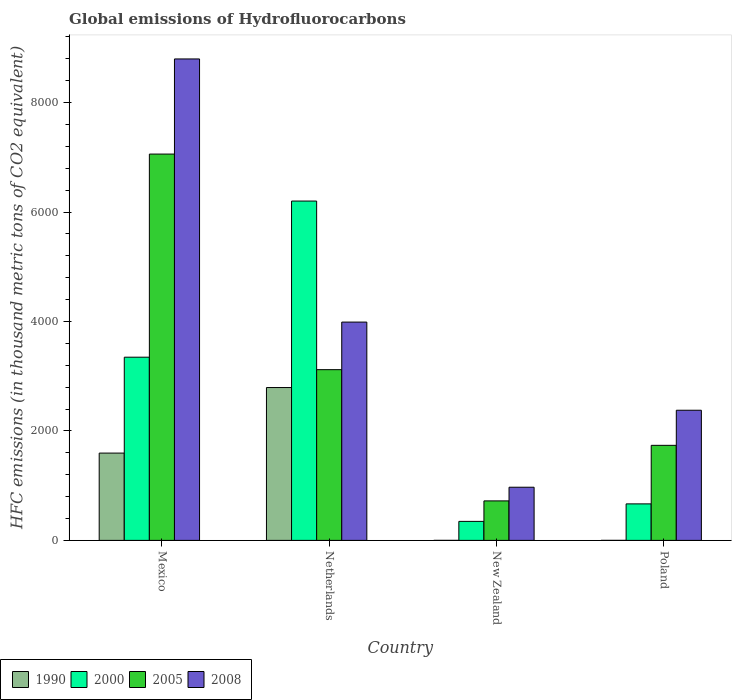How many groups of bars are there?
Give a very brief answer. 4. How many bars are there on the 4th tick from the right?
Offer a very short reply. 4. What is the label of the 4th group of bars from the left?
Keep it short and to the point. Poland. What is the global emissions of Hydrofluorocarbons in 2000 in Mexico?
Provide a short and direct response. 3347.3. Across all countries, what is the maximum global emissions of Hydrofluorocarbons in 1990?
Offer a very short reply. 2792.9. Across all countries, what is the minimum global emissions of Hydrofluorocarbons in 1990?
Offer a terse response. 0.1. In which country was the global emissions of Hydrofluorocarbons in 2000 minimum?
Ensure brevity in your answer.  New Zealand. What is the total global emissions of Hydrofluorocarbons in 2008 in the graph?
Your response must be concise. 1.61e+04. What is the difference between the global emissions of Hydrofluorocarbons in 2008 in Netherlands and that in New Zealand?
Offer a very short reply. 3017.4. What is the difference between the global emissions of Hydrofluorocarbons in 2005 in Netherlands and the global emissions of Hydrofluorocarbons in 2008 in New Zealand?
Offer a terse response. 2148.1. What is the average global emissions of Hydrofluorocarbons in 2008 per country?
Your answer should be compact. 4033.78. What is the difference between the global emissions of Hydrofluorocarbons of/in 1990 and global emissions of Hydrofluorocarbons of/in 2005 in Poland?
Offer a terse response. -1736.6. What is the ratio of the global emissions of Hydrofluorocarbons in 2008 in Netherlands to that in Poland?
Give a very brief answer. 1.68. Is the global emissions of Hydrofluorocarbons in 2008 in New Zealand less than that in Poland?
Provide a short and direct response. Yes. Is the difference between the global emissions of Hydrofluorocarbons in 1990 in New Zealand and Poland greater than the difference between the global emissions of Hydrofluorocarbons in 2005 in New Zealand and Poland?
Give a very brief answer. Yes. What is the difference between the highest and the second highest global emissions of Hydrofluorocarbons in 2000?
Your response must be concise. 2853.1. What is the difference between the highest and the lowest global emissions of Hydrofluorocarbons in 2005?
Provide a short and direct response. 6337.2. What does the 4th bar from the left in Netherlands represents?
Offer a terse response. 2008. Is it the case that in every country, the sum of the global emissions of Hydrofluorocarbons in 2008 and global emissions of Hydrofluorocarbons in 2000 is greater than the global emissions of Hydrofluorocarbons in 2005?
Give a very brief answer. Yes. How many countries are there in the graph?
Ensure brevity in your answer.  4. Are the values on the major ticks of Y-axis written in scientific E-notation?
Make the answer very short. No. Does the graph contain grids?
Offer a very short reply. No. How are the legend labels stacked?
Provide a succinct answer. Horizontal. What is the title of the graph?
Offer a terse response. Global emissions of Hydrofluorocarbons. Does "2015" appear as one of the legend labels in the graph?
Ensure brevity in your answer.  No. What is the label or title of the X-axis?
Your answer should be compact. Country. What is the label or title of the Y-axis?
Offer a very short reply. HFC emissions (in thousand metric tons of CO2 equivalent). What is the HFC emissions (in thousand metric tons of CO2 equivalent) of 1990 in Mexico?
Give a very brief answer. 1595.3. What is the HFC emissions (in thousand metric tons of CO2 equivalent) in 2000 in Mexico?
Provide a short and direct response. 3347.3. What is the HFC emissions (in thousand metric tons of CO2 equivalent) in 2005 in Mexico?
Your response must be concise. 7058.9. What is the HFC emissions (in thousand metric tons of CO2 equivalent) in 2008 in Mexico?
Offer a very short reply. 8796.9. What is the HFC emissions (in thousand metric tons of CO2 equivalent) in 1990 in Netherlands?
Your answer should be very brief. 2792.9. What is the HFC emissions (in thousand metric tons of CO2 equivalent) in 2000 in Netherlands?
Offer a very short reply. 6200.4. What is the HFC emissions (in thousand metric tons of CO2 equivalent) of 2005 in Netherlands?
Offer a very short reply. 3119.5. What is the HFC emissions (in thousand metric tons of CO2 equivalent) in 2008 in Netherlands?
Your answer should be compact. 3988.8. What is the HFC emissions (in thousand metric tons of CO2 equivalent) in 1990 in New Zealand?
Your answer should be very brief. 0.2. What is the HFC emissions (in thousand metric tons of CO2 equivalent) in 2000 in New Zealand?
Your answer should be compact. 347.3. What is the HFC emissions (in thousand metric tons of CO2 equivalent) in 2005 in New Zealand?
Offer a terse response. 721.7. What is the HFC emissions (in thousand metric tons of CO2 equivalent) in 2008 in New Zealand?
Your answer should be compact. 971.4. What is the HFC emissions (in thousand metric tons of CO2 equivalent) in 1990 in Poland?
Give a very brief answer. 0.1. What is the HFC emissions (in thousand metric tons of CO2 equivalent) of 2000 in Poland?
Provide a succinct answer. 667.2. What is the HFC emissions (in thousand metric tons of CO2 equivalent) of 2005 in Poland?
Give a very brief answer. 1736.7. What is the HFC emissions (in thousand metric tons of CO2 equivalent) in 2008 in Poland?
Your answer should be compact. 2378. Across all countries, what is the maximum HFC emissions (in thousand metric tons of CO2 equivalent) in 1990?
Your answer should be very brief. 2792.9. Across all countries, what is the maximum HFC emissions (in thousand metric tons of CO2 equivalent) of 2000?
Provide a short and direct response. 6200.4. Across all countries, what is the maximum HFC emissions (in thousand metric tons of CO2 equivalent) of 2005?
Give a very brief answer. 7058.9. Across all countries, what is the maximum HFC emissions (in thousand metric tons of CO2 equivalent) in 2008?
Ensure brevity in your answer.  8796.9. Across all countries, what is the minimum HFC emissions (in thousand metric tons of CO2 equivalent) of 1990?
Your response must be concise. 0.1. Across all countries, what is the minimum HFC emissions (in thousand metric tons of CO2 equivalent) in 2000?
Provide a succinct answer. 347.3. Across all countries, what is the minimum HFC emissions (in thousand metric tons of CO2 equivalent) of 2005?
Give a very brief answer. 721.7. Across all countries, what is the minimum HFC emissions (in thousand metric tons of CO2 equivalent) in 2008?
Give a very brief answer. 971.4. What is the total HFC emissions (in thousand metric tons of CO2 equivalent) of 1990 in the graph?
Give a very brief answer. 4388.5. What is the total HFC emissions (in thousand metric tons of CO2 equivalent) in 2000 in the graph?
Your answer should be compact. 1.06e+04. What is the total HFC emissions (in thousand metric tons of CO2 equivalent) in 2005 in the graph?
Your answer should be very brief. 1.26e+04. What is the total HFC emissions (in thousand metric tons of CO2 equivalent) in 2008 in the graph?
Ensure brevity in your answer.  1.61e+04. What is the difference between the HFC emissions (in thousand metric tons of CO2 equivalent) in 1990 in Mexico and that in Netherlands?
Provide a short and direct response. -1197.6. What is the difference between the HFC emissions (in thousand metric tons of CO2 equivalent) in 2000 in Mexico and that in Netherlands?
Your answer should be compact. -2853.1. What is the difference between the HFC emissions (in thousand metric tons of CO2 equivalent) in 2005 in Mexico and that in Netherlands?
Give a very brief answer. 3939.4. What is the difference between the HFC emissions (in thousand metric tons of CO2 equivalent) of 2008 in Mexico and that in Netherlands?
Offer a very short reply. 4808.1. What is the difference between the HFC emissions (in thousand metric tons of CO2 equivalent) in 1990 in Mexico and that in New Zealand?
Offer a terse response. 1595.1. What is the difference between the HFC emissions (in thousand metric tons of CO2 equivalent) of 2000 in Mexico and that in New Zealand?
Keep it short and to the point. 3000. What is the difference between the HFC emissions (in thousand metric tons of CO2 equivalent) of 2005 in Mexico and that in New Zealand?
Provide a short and direct response. 6337.2. What is the difference between the HFC emissions (in thousand metric tons of CO2 equivalent) in 2008 in Mexico and that in New Zealand?
Offer a terse response. 7825.5. What is the difference between the HFC emissions (in thousand metric tons of CO2 equivalent) in 1990 in Mexico and that in Poland?
Provide a succinct answer. 1595.2. What is the difference between the HFC emissions (in thousand metric tons of CO2 equivalent) of 2000 in Mexico and that in Poland?
Provide a succinct answer. 2680.1. What is the difference between the HFC emissions (in thousand metric tons of CO2 equivalent) of 2005 in Mexico and that in Poland?
Offer a very short reply. 5322.2. What is the difference between the HFC emissions (in thousand metric tons of CO2 equivalent) in 2008 in Mexico and that in Poland?
Provide a succinct answer. 6418.9. What is the difference between the HFC emissions (in thousand metric tons of CO2 equivalent) in 1990 in Netherlands and that in New Zealand?
Your answer should be very brief. 2792.7. What is the difference between the HFC emissions (in thousand metric tons of CO2 equivalent) in 2000 in Netherlands and that in New Zealand?
Your answer should be compact. 5853.1. What is the difference between the HFC emissions (in thousand metric tons of CO2 equivalent) of 2005 in Netherlands and that in New Zealand?
Make the answer very short. 2397.8. What is the difference between the HFC emissions (in thousand metric tons of CO2 equivalent) of 2008 in Netherlands and that in New Zealand?
Provide a succinct answer. 3017.4. What is the difference between the HFC emissions (in thousand metric tons of CO2 equivalent) in 1990 in Netherlands and that in Poland?
Your response must be concise. 2792.8. What is the difference between the HFC emissions (in thousand metric tons of CO2 equivalent) in 2000 in Netherlands and that in Poland?
Provide a short and direct response. 5533.2. What is the difference between the HFC emissions (in thousand metric tons of CO2 equivalent) in 2005 in Netherlands and that in Poland?
Offer a very short reply. 1382.8. What is the difference between the HFC emissions (in thousand metric tons of CO2 equivalent) in 2008 in Netherlands and that in Poland?
Ensure brevity in your answer.  1610.8. What is the difference between the HFC emissions (in thousand metric tons of CO2 equivalent) of 1990 in New Zealand and that in Poland?
Ensure brevity in your answer.  0.1. What is the difference between the HFC emissions (in thousand metric tons of CO2 equivalent) of 2000 in New Zealand and that in Poland?
Your answer should be compact. -319.9. What is the difference between the HFC emissions (in thousand metric tons of CO2 equivalent) in 2005 in New Zealand and that in Poland?
Make the answer very short. -1015. What is the difference between the HFC emissions (in thousand metric tons of CO2 equivalent) in 2008 in New Zealand and that in Poland?
Keep it short and to the point. -1406.6. What is the difference between the HFC emissions (in thousand metric tons of CO2 equivalent) in 1990 in Mexico and the HFC emissions (in thousand metric tons of CO2 equivalent) in 2000 in Netherlands?
Give a very brief answer. -4605.1. What is the difference between the HFC emissions (in thousand metric tons of CO2 equivalent) of 1990 in Mexico and the HFC emissions (in thousand metric tons of CO2 equivalent) of 2005 in Netherlands?
Ensure brevity in your answer.  -1524.2. What is the difference between the HFC emissions (in thousand metric tons of CO2 equivalent) of 1990 in Mexico and the HFC emissions (in thousand metric tons of CO2 equivalent) of 2008 in Netherlands?
Give a very brief answer. -2393.5. What is the difference between the HFC emissions (in thousand metric tons of CO2 equivalent) of 2000 in Mexico and the HFC emissions (in thousand metric tons of CO2 equivalent) of 2005 in Netherlands?
Give a very brief answer. 227.8. What is the difference between the HFC emissions (in thousand metric tons of CO2 equivalent) of 2000 in Mexico and the HFC emissions (in thousand metric tons of CO2 equivalent) of 2008 in Netherlands?
Ensure brevity in your answer.  -641.5. What is the difference between the HFC emissions (in thousand metric tons of CO2 equivalent) of 2005 in Mexico and the HFC emissions (in thousand metric tons of CO2 equivalent) of 2008 in Netherlands?
Keep it short and to the point. 3070.1. What is the difference between the HFC emissions (in thousand metric tons of CO2 equivalent) in 1990 in Mexico and the HFC emissions (in thousand metric tons of CO2 equivalent) in 2000 in New Zealand?
Your answer should be very brief. 1248. What is the difference between the HFC emissions (in thousand metric tons of CO2 equivalent) of 1990 in Mexico and the HFC emissions (in thousand metric tons of CO2 equivalent) of 2005 in New Zealand?
Give a very brief answer. 873.6. What is the difference between the HFC emissions (in thousand metric tons of CO2 equivalent) in 1990 in Mexico and the HFC emissions (in thousand metric tons of CO2 equivalent) in 2008 in New Zealand?
Offer a terse response. 623.9. What is the difference between the HFC emissions (in thousand metric tons of CO2 equivalent) in 2000 in Mexico and the HFC emissions (in thousand metric tons of CO2 equivalent) in 2005 in New Zealand?
Your response must be concise. 2625.6. What is the difference between the HFC emissions (in thousand metric tons of CO2 equivalent) in 2000 in Mexico and the HFC emissions (in thousand metric tons of CO2 equivalent) in 2008 in New Zealand?
Provide a short and direct response. 2375.9. What is the difference between the HFC emissions (in thousand metric tons of CO2 equivalent) in 2005 in Mexico and the HFC emissions (in thousand metric tons of CO2 equivalent) in 2008 in New Zealand?
Your response must be concise. 6087.5. What is the difference between the HFC emissions (in thousand metric tons of CO2 equivalent) of 1990 in Mexico and the HFC emissions (in thousand metric tons of CO2 equivalent) of 2000 in Poland?
Keep it short and to the point. 928.1. What is the difference between the HFC emissions (in thousand metric tons of CO2 equivalent) of 1990 in Mexico and the HFC emissions (in thousand metric tons of CO2 equivalent) of 2005 in Poland?
Offer a terse response. -141.4. What is the difference between the HFC emissions (in thousand metric tons of CO2 equivalent) in 1990 in Mexico and the HFC emissions (in thousand metric tons of CO2 equivalent) in 2008 in Poland?
Provide a short and direct response. -782.7. What is the difference between the HFC emissions (in thousand metric tons of CO2 equivalent) of 2000 in Mexico and the HFC emissions (in thousand metric tons of CO2 equivalent) of 2005 in Poland?
Offer a terse response. 1610.6. What is the difference between the HFC emissions (in thousand metric tons of CO2 equivalent) in 2000 in Mexico and the HFC emissions (in thousand metric tons of CO2 equivalent) in 2008 in Poland?
Make the answer very short. 969.3. What is the difference between the HFC emissions (in thousand metric tons of CO2 equivalent) of 2005 in Mexico and the HFC emissions (in thousand metric tons of CO2 equivalent) of 2008 in Poland?
Your answer should be compact. 4680.9. What is the difference between the HFC emissions (in thousand metric tons of CO2 equivalent) of 1990 in Netherlands and the HFC emissions (in thousand metric tons of CO2 equivalent) of 2000 in New Zealand?
Your answer should be compact. 2445.6. What is the difference between the HFC emissions (in thousand metric tons of CO2 equivalent) in 1990 in Netherlands and the HFC emissions (in thousand metric tons of CO2 equivalent) in 2005 in New Zealand?
Your answer should be very brief. 2071.2. What is the difference between the HFC emissions (in thousand metric tons of CO2 equivalent) in 1990 in Netherlands and the HFC emissions (in thousand metric tons of CO2 equivalent) in 2008 in New Zealand?
Make the answer very short. 1821.5. What is the difference between the HFC emissions (in thousand metric tons of CO2 equivalent) in 2000 in Netherlands and the HFC emissions (in thousand metric tons of CO2 equivalent) in 2005 in New Zealand?
Your answer should be compact. 5478.7. What is the difference between the HFC emissions (in thousand metric tons of CO2 equivalent) of 2000 in Netherlands and the HFC emissions (in thousand metric tons of CO2 equivalent) of 2008 in New Zealand?
Make the answer very short. 5229. What is the difference between the HFC emissions (in thousand metric tons of CO2 equivalent) in 2005 in Netherlands and the HFC emissions (in thousand metric tons of CO2 equivalent) in 2008 in New Zealand?
Provide a short and direct response. 2148.1. What is the difference between the HFC emissions (in thousand metric tons of CO2 equivalent) in 1990 in Netherlands and the HFC emissions (in thousand metric tons of CO2 equivalent) in 2000 in Poland?
Offer a very short reply. 2125.7. What is the difference between the HFC emissions (in thousand metric tons of CO2 equivalent) in 1990 in Netherlands and the HFC emissions (in thousand metric tons of CO2 equivalent) in 2005 in Poland?
Ensure brevity in your answer.  1056.2. What is the difference between the HFC emissions (in thousand metric tons of CO2 equivalent) in 1990 in Netherlands and the HFC emissions (in thousand metric tons of CO2 equivalent) in 2008 in Poland?
Your response must be concise. 414.9. What is the difference between the HFC emissions (in thousand metric tons of CO2 equivalent) in 2000 in Netherlands and the HFC emissions (in thousand metric tons of CO2 equivalent) in 2005 in Poland?
Offer a terse response. 4463.7. What is the difference between the HFC emissions (in thousand metric tons of CO2 equivalent) in 2000 in Netherlands and the HFC emissions (in thousand metric tons of CO2 equivalent) in 2008 in Poland?
Provide a short and direct response. 3822.4. What is the difference between the HFC emissions (in thousand metric tons of CO2 equivalent) in 2005 in Netherlands and the HFC emissions (in thousand metric tons of CO2 equivalent) in 2008 in Poland?
Keep it short and to the point. 741.5. What is the difference between the HFC emissions (in thousand metric tons of CO2 equivalent) of 1990 in New Zealand and the HFC emissions (in thousand metric tons of CO2 equivalent) of 2000 in Poland?
Give a very brief answer. -667. What is the difference between the HFC emissions (in thousand metric tons of CO2 equivalent) in 1990 in New Zealand and the HFC emissions (in thousand metric tons of CO2 equivalent) in 2005 in Poland?
Give a very brief answer. -1736.5. What is the difference between the HFC emissions (in thousand metric tons of CO2 equivalent) of 1990 in New Zealand and the HFC emissions (in thousand metric tons of CO2 equivalent) of 2008 in Poland?
Ensure brevity in your answer.  -2377.8. What is the difference between the HFC emissions (in thousand metric tons of CO2 equivalent) in 2000 in New Zealand and the HFC emissions (in thousand metric tons of CO2 equivalent) in 2005 in Poland?
Your answer should be compact. -1389.4. What is the difference between the HFC emissions (in thousand metric tons of CO2 equivalent) of 2000 in New Zealand and the HFC emissions (in thousand metric tons of CO2 equivalent) of 2008 in Poland?
Provide a succinct answer. -2030.7. What is the difference between the HFC emissions (in thousand metric tons of CO2 equivalent) in 2005 in New Zealand and the HFC emissions (in thousand metric tons of CO2 equivalent) in 2008 in Poland?
Make the answer very short. -1656.3. What is the average HFC emissions (in thousand metric tons of CO2 equivalent) in 1990 per country?
Make the answer very short. 1097.12. What is the average HFC emissions (in thousand metric tons of CO2 equivalent) in 2000 per country?
Give a very brief answer. 2640.55. What is the average HFC emissions (in thousand metric tons of CO2 equivalent) of 2005 per country?
Give a very brief answer. 3159.2. What is the average HFC emissions (in thousand metric tons of CO2 equivalent) in 2008 per country?
Your answer should be compact. 4033.78. What is the difference between the HFC emissions (in thousand metric tons of CO2 equivalent) of 1990 and HFC emissions (in thousand metric tons of CO2 equivalent) of 2000 in Mexico?
Provide a succinct answer. -1752. What is the difference between the HFC emissions (in thousand metric tons of CO2 equivalent) of 1990 and HFC emissions (in thousand metric tons of CO2 equivalent) of 2005 in Mexico?
Keep it short and to the point. -5463.6. What is the difference between the HFC emissions (in thousand metric tons of CO2 equivalent) in 1990 and HFC emissions (in thousand metric tons of CO2 equivalent) in 2008 in Mexico?
Provide a short and direct response. -7201.6. What is the difference between the HFC emissions (in thousand metric tons of CO2 equivalent) in 2000 and HFC emissions (in thousand metric tons of CO2 equivalent) in 2005 in Mexico?
Provide a succinct answer. -3711.6. What is the difference between the HFC emissions (in thousand metric tons of CO2 equivalent) of 2000 and HFC emissions (in thousand metric tons of CO2 equivalent) of 2008 in Mexico?
Give a very brief answer. -5449.6. What is the difference between the HFC emissions (in thousand metric tons of CO2 equivalent) in 2005 and HFC emissions (in thousand metric tons of CO2 equivalent) in 2008 in Mexico?
Keep it short and to the point. -1738. What is the difference between the HFC emissions (in thousand metric tons of CO2 equivalent) of 1990 and HFC emissions (in thousand metric tons of CO2 equivalent) of 2000 in Netherlands?
Offer a very short reply. -3407.5. What is the difference between the HFC emissions (in thousand metric tons of CO2 equivalent) in 1990 and HFC emissions (in thousand metric tons of CO2 equivalent) in 2005 in Netherlands?
Give a very brief answer. -326.6. What is the difference between the HFC emissions (in thousand metric tons of CO2 equivalent) in 1990 and HFC emissions (in thousand metric tons of CO2 equivalent) in 2008 in Netherlands?
Your response must be concise. -1195.9. What is the difference between the HFC emissions (in thousand metric tons of CO2 equivalent) in 2000 and HFC emissions (in thousand metric tons of CO2 equivalent) in 2005 in Netherlands?
Your answer should be compact. 3080.9. What is the difference between the HFC emissions (in thousand metric tons of CO2 equivalent) of 2000 and HFC emissions (in thousand metric tons of CO2 equivalent) of 2008 in Netherlands?
Provide a succinct answer. 2211.6. What is the difference between the HFC emissions (in thousand metric tons of CO2 equivalent) in 2005 and HFC emissions (in thousand metric tons of CO2 equivalent) in 2008 in Netherlands?
Your answer should be compact. -869.3. What is the difference between the HFC emissions (in thousand metric tons of CO2 equivalent) in 1990 and HFC emissions (in thousand metric tons of CO2 equivalent) in 2000 in New Zealand?
Ensure brevity in your answer.  -347.1. What is the difference between the HFC emissions (in thousand metric tons of CO2 equivalent) in 1990 and HFC emissions (in thousand metric tons of CO2 equivalent) in 2005 in New Zealand?
Make the answer very short. -721.5. What is the difference between the HFC emissions (in thousand metric tons of CO2 equivalent) of 1990 and HFC emissions (in thousand metric tons of CO2 equivalent) of 2008 in New Zealand?
Offer a terse response. -971.2. What is the difference between the HFC emissions (in thousand metric tons of CO2 equivalent) of 2000 and HFC emissions (in thousand metric tons of CO2 equivalent) of 2005 in New Zealand?
Provide a short and direct response. -374.4. What is the difference between the HFC emissions (in thousand metric tons of CO2 equivalent) of 2000 and HFC emissions (in thousand metric tons of CO2 equivalent) of 2008 in New Zealand?
Your answer should be compact. -624.1. What is the difference between the HFC emissions (in thousand metric tons of CO2 equivalent) of 2005 and HFC emissions (in thousand metric tons of CO2 equivalent) of 2008 in New Zealand?
Your answer should be very brief. -249.7. What is the difference between the HFC emissions (in thousand metric tons of CO2 equivalent) in 1990 and HFC emissions (in thousand metric tons of CO2 equivalent) in 2000 in Poland?
Offer a terse response. -667.1. What is the difference between the HFC emissions (in thousand metric tons of CO2 equivalent) in 1990 and HFC emissions (in thousand metric tons of CO2 equivalent) in 2005 in Poland?
Give a very brief answer. -1736.6. What is the difference between the HFC emissions (in thousand metric tons of CO2 equivalent) in 1990 and HFC emissions (in thousand metric tons of CO2 equivalent) in 2008 in Poland?
Provide a succinct answer. -2377.9. What is the difference between the HFC emissions (in thousand metric tons of CO2 equivalent) in 2000 and HFC emissions (in thousand metric tons of CO2 equivalent) in 2005 in Poland?
Your answer should be very brief. -1069.5. What is the difference between the HFC emissions (in thousand metric tons of CO2 equivalent) of 2000 and HFC emissions (in thousand metric tons of CO2 equivalent) of 2008 in Poland?
Make the answer very short. -1710.8. What is the difference between the HFC emissions (in thousand metric tons of CO2 equivalent) in 2005 and HFC emissions (in thousand metric tons of CO2 equivalent) in 2008 in Poland?
Provide a succinct answer. -641.3. What is the ratio of the HFC emissions (in thousand metric tons of CO2 equivalent) in 1990 in Mexico to that in Netherlands?
Your answer should be very brief. 0.57. What is the ratio of the HFC emissions (in thousand metric tons of CO2 equivalent) of 2000 in Mexico to that in Netherlands?
Your answer should be very brief. 0.54. What is the ratio of the HFC emissions (in thousand metric tons of CO2 equivalent) in 2005 in Mexico to that in Netherlands?
Your answer should be compact. 2.26. What is the ratio of the HFC emissions (in thousand metric tons of CO2 equivalent) of 2008 in Mexico to that in Netherlands?
Offer a very short reply. 2.21. What is the ratio of the HFC emissions (in thousand metric tons of CO2 equivalent) in 1990 in Mexico to that in New Zealand?
Your answer should be compact. 7976.5. What is the ratio of the HFC emissions (in thousand metric tons of CO2 equivalent) of 2000 in Mexico to that in New Zealand?
Provide a short and direct response. 9.64. What is the ratio of the HFC emissions (in thousand metric tons of CO2 equivalent) in 2005 in Mexico to that in New Zealand?
Ensure brevity in your answer.  9.78. What is the ratio of the HFC emissions (in thousand metric tons of CO2 equivalent) of 2008 in Mexico to that in New Zealand?
Ensure brevity in your answer.  9.06. What is the ratio of the HFC emissions (in thousand metric tons of CO2 equivalent) of 1990 in Mexico to that in Poland?
Provide a short and direct response. 1.60e+04. What is the ratio of the HFC emissions (in thousand metric tons of CO2 equivalent) of 2000 in Mexico to that in Poland?
Keep it short and to the point. 5.02. What is the ratio of the HFC emissions (in thousand metric tons of CO2 equivalent) in 2005 in Mexico to that in Poland?
Make the answer very short. 4.06. What is the ratio of the HFC emissions (in thousand metric tons of CO2 equivalent) of 2008 in Mexico to that in Poland?
Give a very brief answer. 3.7. What is the ratio of the HFC emissions (in thousand metric tons of CO2 equivalent) of 1990 in Netherlands to that in New Zealand?
Your response must be concise. 1.40e+04. What is the ratio of the HFC emissions (in thousand metric tons of CO2 equivalent) of 2000 in Netherlands to that in New Zealand?
Your response must be concise. 17.85. What is the ratio of the HFC emissions (in thousand metric tons of CO2 equivalent) in 2005 in Netherlands to that in New Zealand?
Offer a very short reply. 4.32. What is the ratio of the HFC emissions (in thousand metric tons of CO2 equivalent) in 2008 in Netherlands to that in New Zealand?
Your response must be concise. 4.11. What is the ratio of the HFC emissions (in thousand metric tons of CO2 equivalent) in 1990 in Netherlands to that in Poland?
Keep it short and to the point. 2.79e+04. What is the ratio of the HFC emissions (in thousand metric tons of CO2 equivalent) in 2000 in Netherlands to that in Poland?
Give a very brief answer. 9.29. What is the ratio of the HFC emissions (in thousand metric tons of CO2 equivalent) of 2005 in Netherlands to that in Poland?
Provide a short and direct response. 1.8. What is the ratio of the HFC emissions (in thousand metric tons of CO2 equivalent) in 2008 in Netherlands to that in Poland?
Offer a terse response. 1.68. What is the ratio of the HFC emissions (in thousand metric tons of CO2 equivalent) of 1990 in New Zealand to that in Poland?
Give a very brief answer. 2. What is the ratio of the HFC emissions (in thousand metric tons of CO2 equivalent) in 2000 in New Zealand to that in Poland?
Keep it short and to the point. 0.52. What is the ratio of the HFC emissions (in thousand metric tons of CO2 equivalent) in 2005 in New Zealand to that in Poland?
Give a very brief answer. 0.42. What is the ratio of the HFC emissions (in thousand metric tons of CO2 equivalent) of 2008 in New Zealand to that in Poland?
Provide a short and direct response. 0.41. What is the difference between the highest and the second highest HFC emissions (in thousand metric tons of CO2 equivalent) in 1990?
Give a very brief answer. 1197.6. What is the difference between the highest and the second highest HFC emissions (in thousand metric tons of CO2 equivalent) of 2000?
Your answer should be compact. 2853.1. What is the difference between the highest and the second highest HFC emissions (in thousand metric tons of CO2 equivalent) in 2005?
Provide a succinct answer. 3939.4. What is the difference between the highest and the second highest HFC emissions (in thousand metric tons of CO2 equivalent) in 2008?
Your answer should be compact. 4808.1. What is the difference between the highest and the lowest HFC emissions (in thousand metric tons of CO2 equivalent) of 1990?
Give a very brief answer. 2792.8. What is the difference between the highest and the lowest HFC emissions (in thousand metric tons of CO2 equivalent) in 2000?
Provide a short and direct response. 5853.1. What is the difference between the highest and the lowest HFC emissions (in thousand metric tons of CO2 equivalent) in 2005?
Keep it short and to the point. 6337.2. What is the difference between the highest and the lowest HFC emissions (in thousand metric tons of CO2 equivalent) in 2008?
Give a very brief answer. 7825.5. 